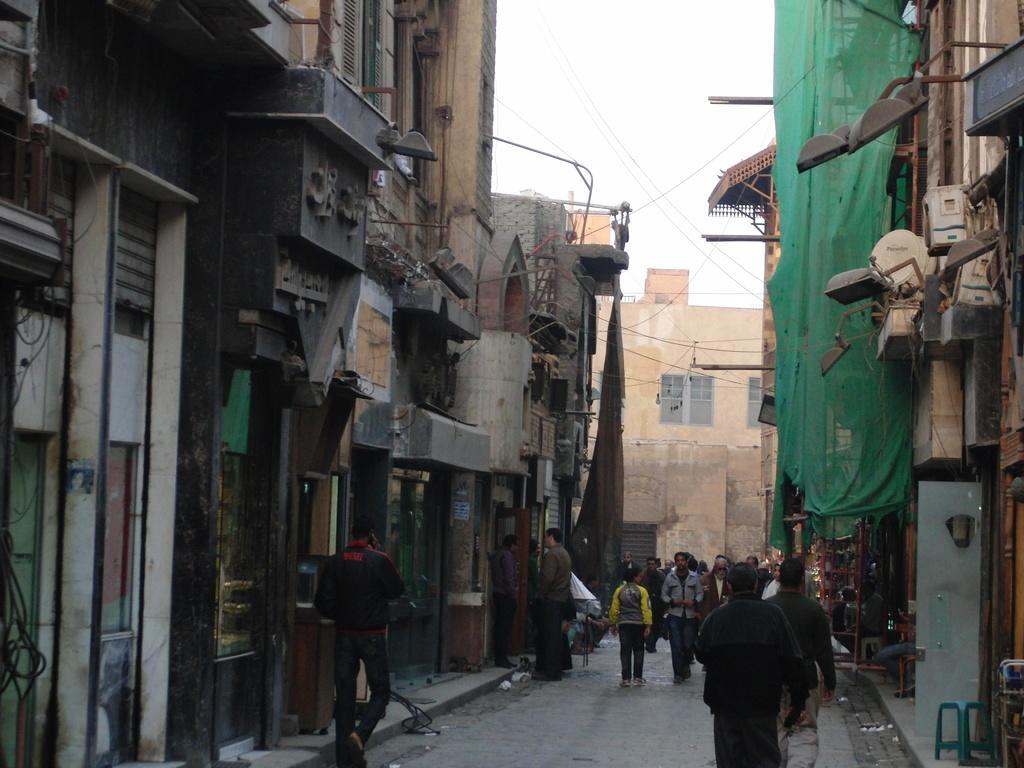In one or two sentences, can you explain what this image depicts? There are group of people walking on a road and there are buildings on the either side and in front of them. 